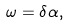<formula> <loc_0><loc_0><loc_500><loc_500>\omega = \delta \alpha ,</formula> 